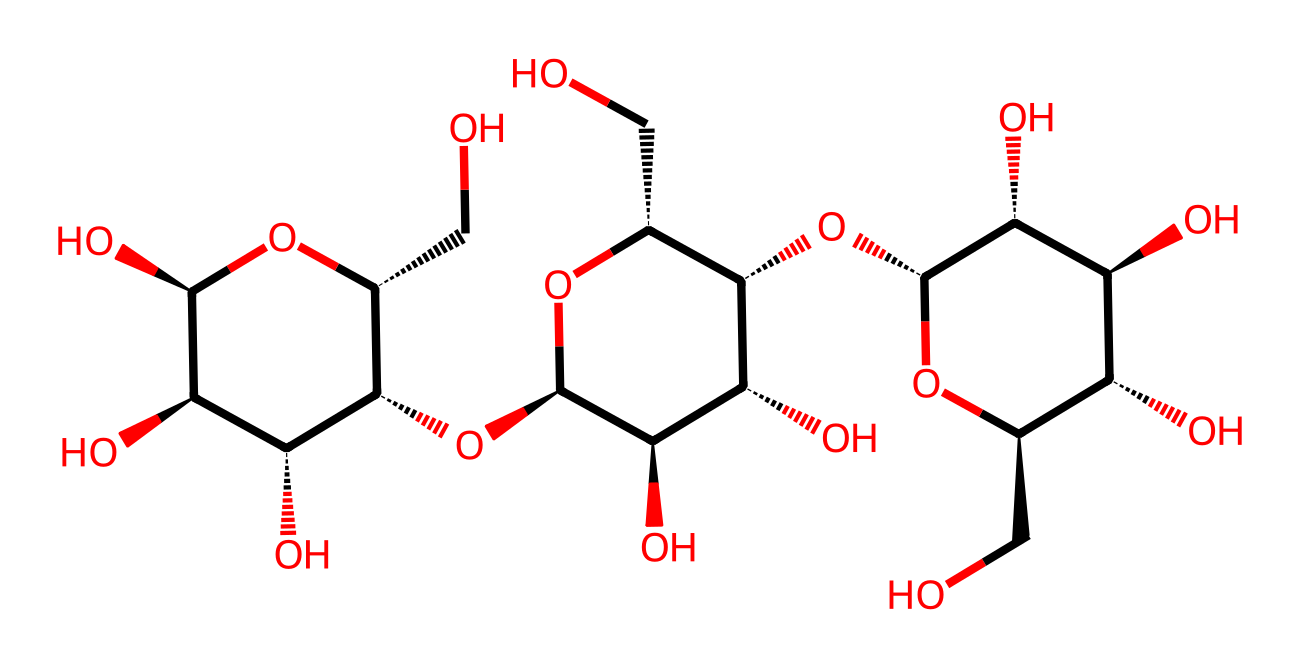What is the main component of paper and cardboard? The chemical structure provided is of cellulose, which is known to be the primary component of both paper and cardboard.
Answer: cellulose How many carbon atoms are present in this structure? By analyzing the provided SMILES notation, there are a total of six distinct carbon atoms present in the cellulose structure.
Answer: six What type of bonds are predominantly found in cellulose? The cellulose structure consists mostly of glycosidic bonds that link individual glucose units together to form the polymer chain.
Answer: glycosidic bonds Which functional group is primarily represented in this chemical? The hydroxyl (-OH) groups are prevalent throughout the structure of cellulose, indicating the presence of alcohol functional groups.
Answer: hydroxyl What is the degree of polymerization in this cellulose molecule? The degree of polymerization refers to the number of monomeric units in the polymer; in cellulose, it is typically around 1000 to several thousand, indicating many repeating units.
Answer: around 1000 What is the stereochemistry around the first carbon atom? The stereochemistry around the first carbon is chiral, indicated by the presence of four different substituents attached to the carbon, making it a chiral center.
Answer: chiral In what form is cellulose most commonly found in nature? Cellulose is commonly found in the form of fibrous structures in plant cell walls, providing the structural integrity and support to the plant.
Answer: fibers 